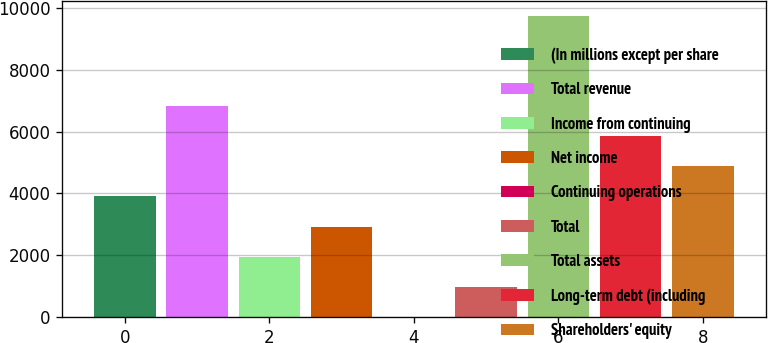Convert chart. <chart><loc_0><loc_0><loc_500><loc_500><bar_chart><fcel>(In millions except per share<fcel>Total revenue<fcel>Income from continuing<fcel>Net income<fcel>Continuing operations<fcel>Total<fcel>Total assets<fcel>Long-term debt (including<fcel>Shareholders' equity<nl><fcel>3899.74<fcel>6821.38<fcel>1951.98<fcel>2925.86<fcel>4.22<fcel>978.1<fcel>9743<fcel>5847.5<fcel>4873.62<nl></chart> 